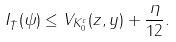Convert formula to latex. <formula><loc_0><loc_0><loc_500><loc_500>I _ { \bar { T } } ( \psi ) \leq V _ { K _ { 0 } ^ { c } } ( z , y ) + \frac { \eta } { 1 2 } .</formula> 